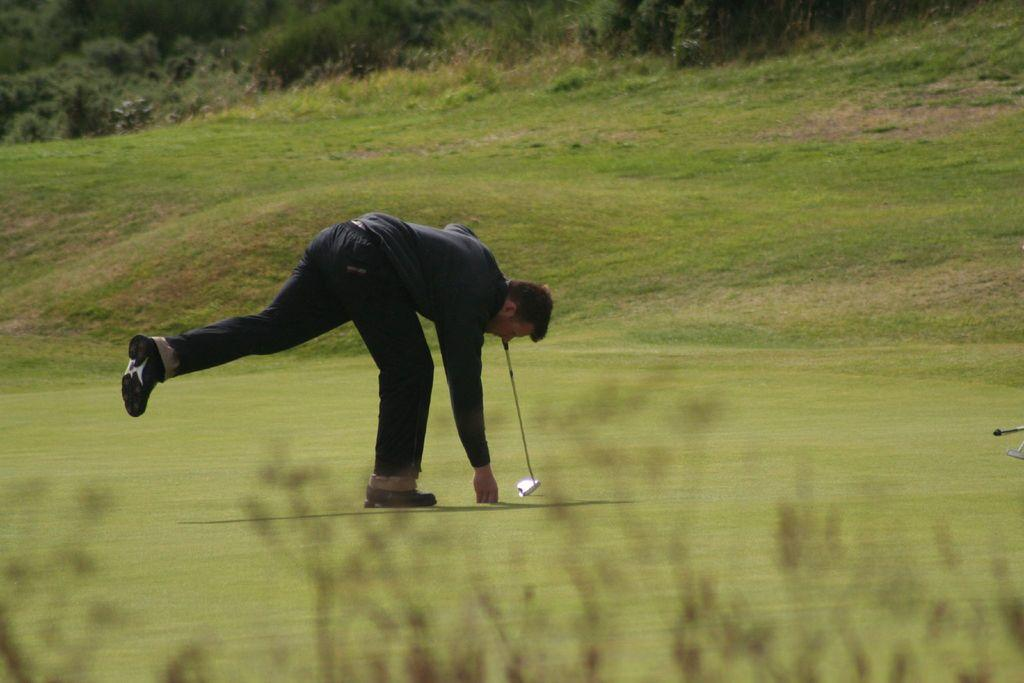Who or what is present in the image? There is a person in the image. What is the person doing in the image? The person is standing on the ground and holding a golf stick. What type of environment is depicted in the image? There are trees and grass in the image, suggesting a natural setting. What type of heat source can be seen in the image? There is no heat source visible in the image. Is the person holding a quiver in the image? No, the person is holding a golf stick, not a quiver. 